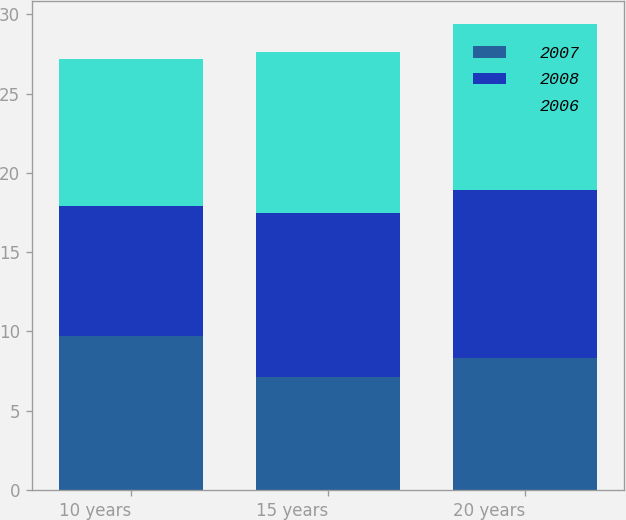Convert chart. <chart><loc_0><loc_0><loc_500><loc_500><stacked_bar_chart><ecel><fcel>10 years<fcel>15 years<fcel>20 years<nl><fcel>2007<fcel>9.7<fcel>7.1<fcel>8.3<nl><fcel>2008<fcel>8.2<fcel>10.4<fcel>10.6<nl><fcel>2006<fcel>9.3<fcel>10.1<fcel>10.5<nl></chart> 